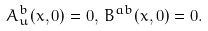Convert formula to latex. <formula><loc_0><loc_0><loc_500><loc_500>A ^ { b } _ { u } ( x , 0 ) = 0 , \, B ^ { a b } ( x , 0 ) = 0 .</formula> 